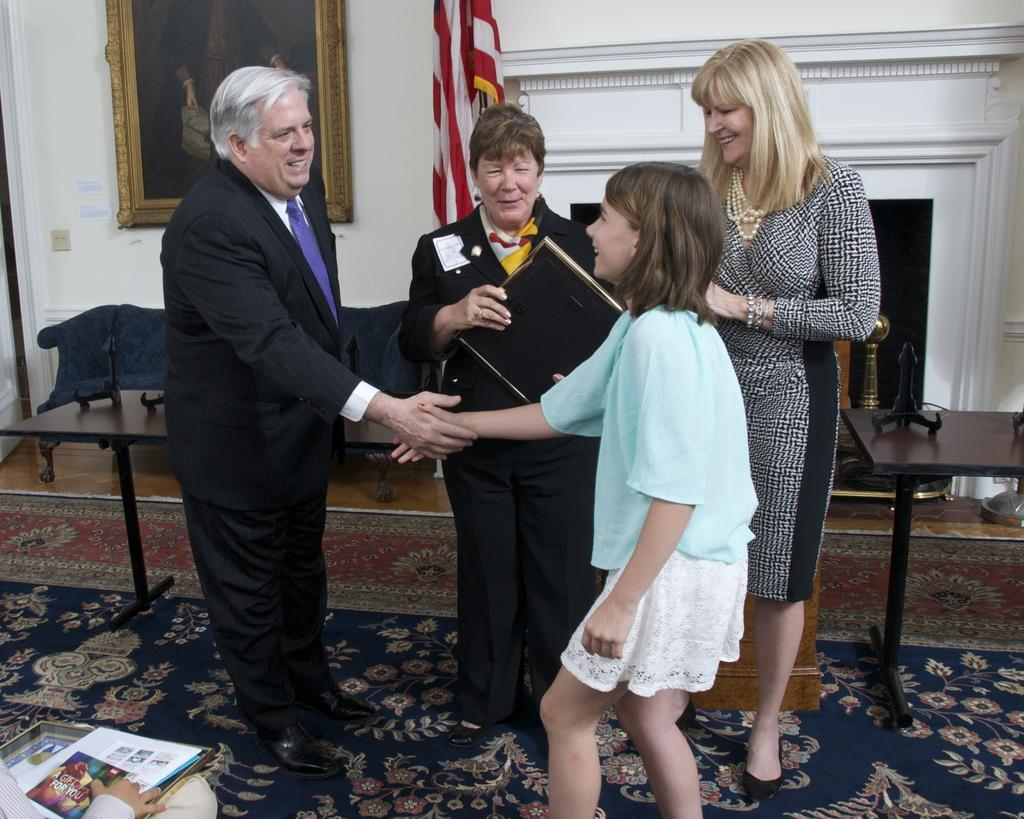What is happening in the foreground of the image? There are people in the foreground of the image. Can you describe the activity of the person at the bottom of the image? Someone is holding papers at the bottom of the image. What can be seen on the wall in the background of the image? There is a photo frame on the wall in the background of the image. What type of wood can be seen in the flesh of the person holding papers in the image? There is no wood or flesh visible in the image; it only shows people, papers, and a photo frame. 